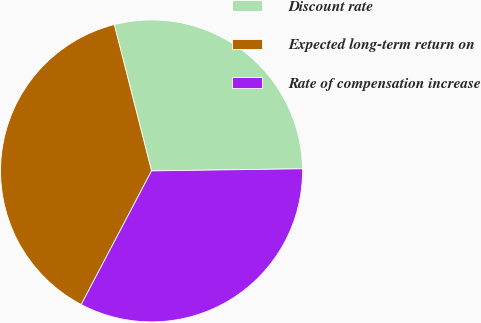Convert chart. <chart><loc_0><loc_0><loc_500><loc_500><pie_chart><fcel>Discount rate<fcel>Expected long-term return on<fcel>Rate of compensation increase<nl><fcel>28.74%<fcel>38.32%<fcel>32.93%<nl></chart> 